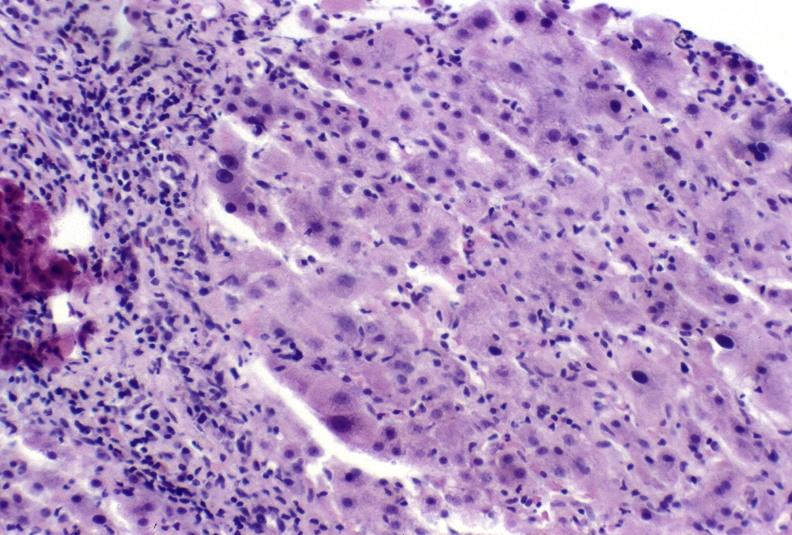what does this image show?
Answer the question using a single word or phrase. Autoimmune hepatitis 